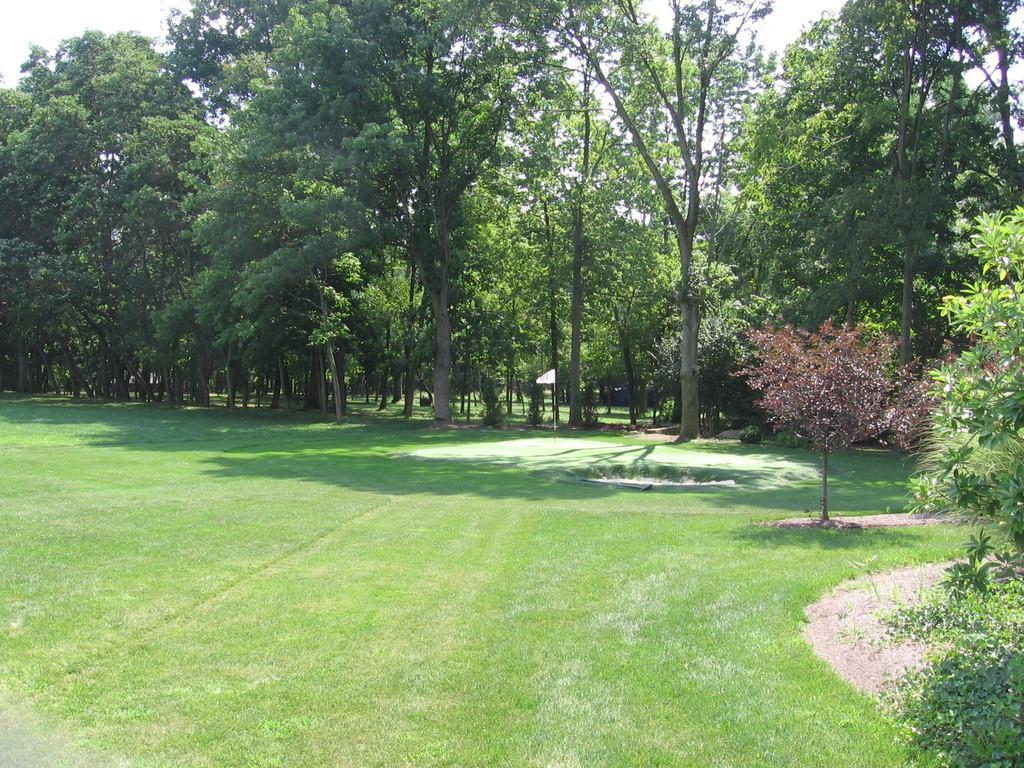Please provide a concise description of this image. In this image in the center there is grass on the ground. In the background there are trees. In the front on the right side there are leaves. 